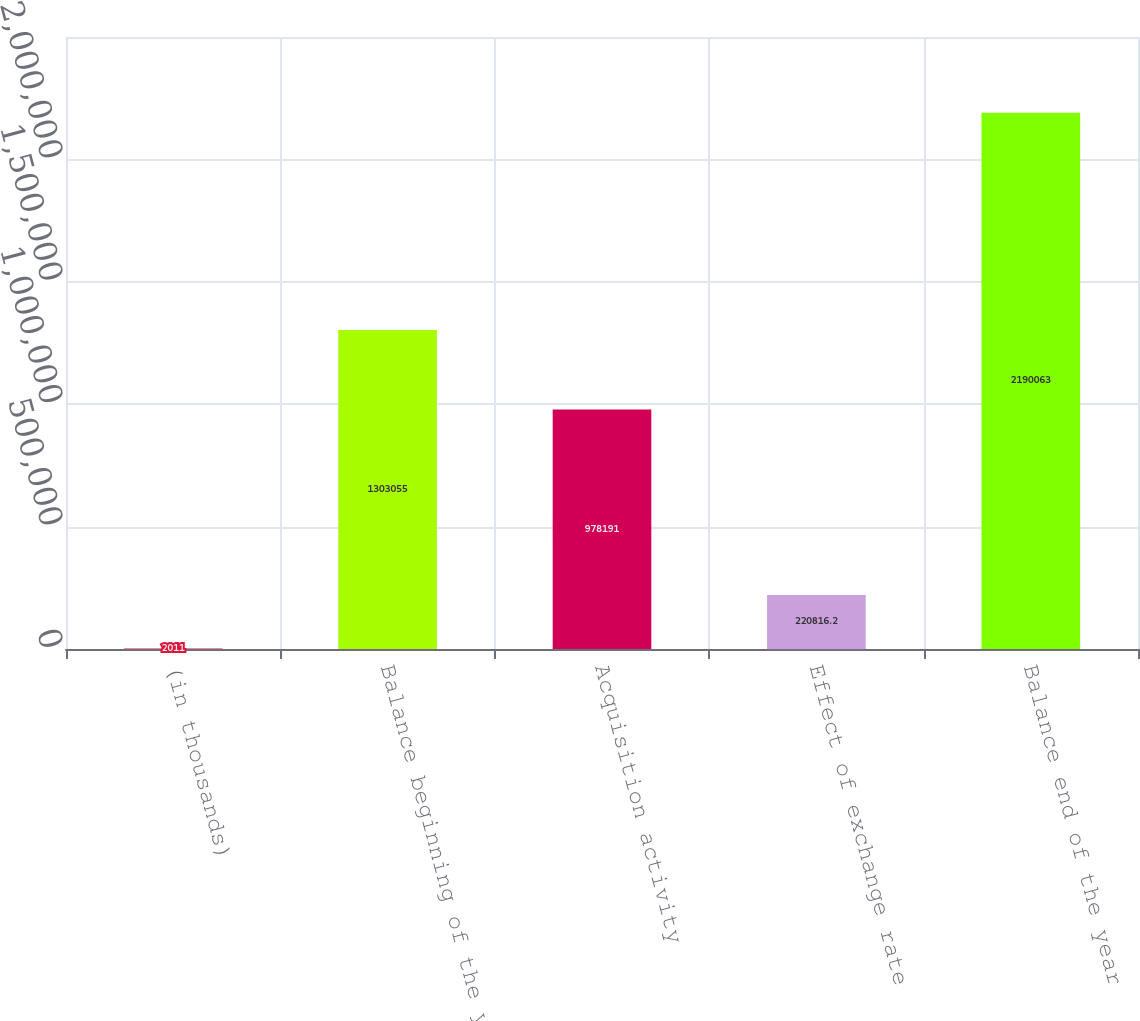Convert chart to OTSL. <chart><loc_0><loc_0><loc_500><loc_500><bar_chart><fcel>(in thousands)<fcel>Balance beginning of the year<fcel>Acquisition activity<fcel>Effect of exchange rate<fcel>Balance end of the year<nl><fcel>2011<fcel>1.30306e+06<fcel>978191<fcel>220816<fcel>2.19006e+06<nl></chart> 